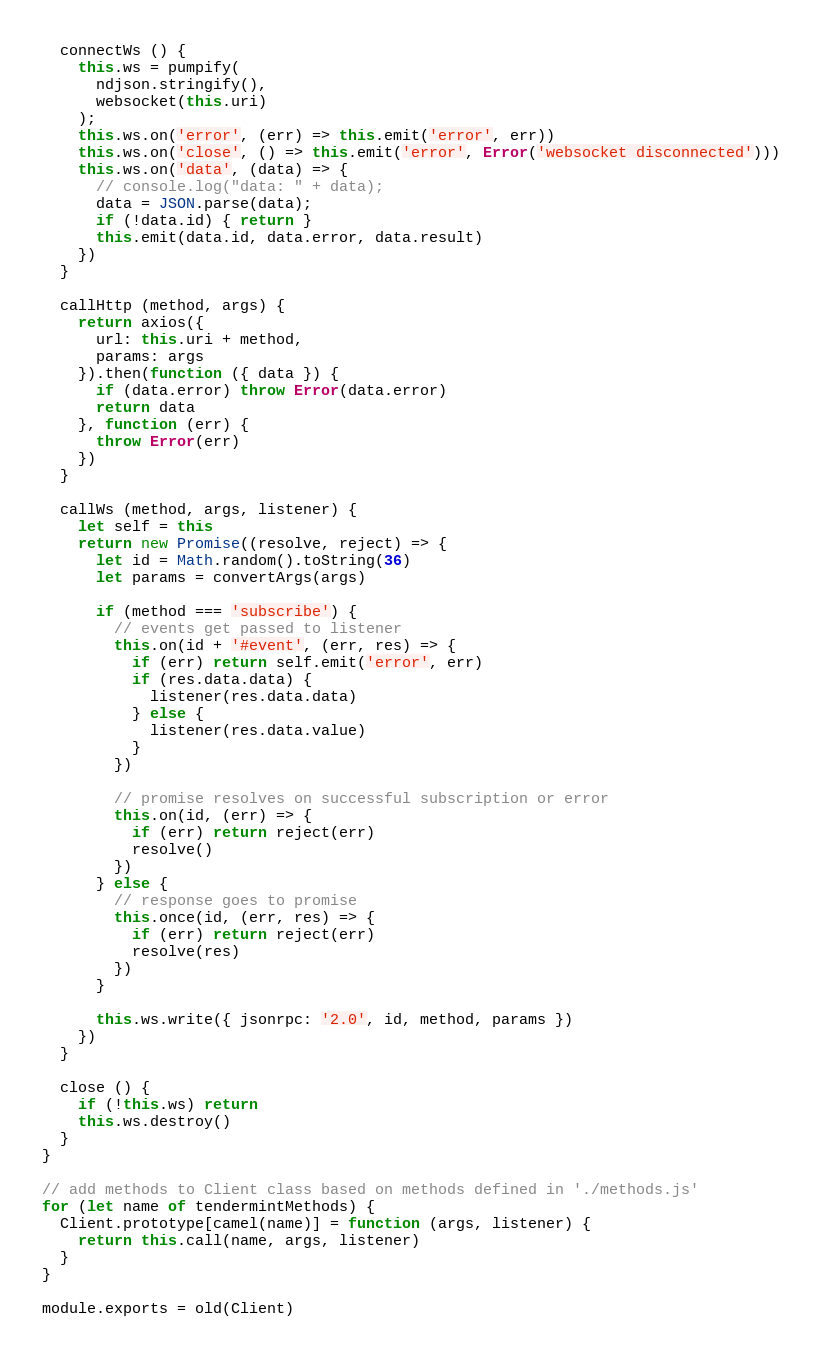<code> <loc_0><loc_0><loc_500><loc_500><_JavaScript_>
  connectWs () {
    this.ws = pumpify(
      ndjson.stringify(),
      websocket(this.uri)
    );
    this.ws.on('error', (err) => this.emit('error', err))
    this.ws.on('close', () => this.emit('error', Error('websocket disconnected')))
    this.ws.on('data', (data) => {
      // console.log("data: " + data);
      data = JSON.parse(data);
      if (!data.id) { return }
      this.emit(data.id, data.error, data.result)
    })
  }

  callHttp (method, args) {
    return axios({
      url: this.uri + method,
      params: args
    }).then(function ({ data }) {
      if (data.error) throw Error(data.error)
      return data
    }, function (err) {
      throw Error(err)
    })
  }

  callWs (method, args, listener) {
    let self = this
    return new Promise((resolve, reject) => {
      let id = Math.random().toString(36)
      let params = convertArgs(args)

      if (method === 'subscribe') {
        // events get passed to listener
        this.on(id + '#event', (err, res) => {
          if (err) return self.emit('error', err)
          if (res.data.data) {
            listener(res.data.data)
          } else {
            listener(res.data.value)
          }
        })

        // promise resolves on successful subscription or error
        this.on(id, (err) => {
          if (err) return reject(err)
          resolve()
        })
      } else {
        // response goes to promise
        this.once(id, (err, res) => {
          if (err) return reject(err)
          resolve(res)
        })
      }

      this.ws.write({ jsonrpc: '2.0', id, method, params })
    })
  }

  close () {
    if (!this.ws) return
    this.ws.destroy()
  }
}

// add methods to Client class based on methods defined in './methods.js'
for (let name of tendermintMethods) {
  Client.prototype[camel(name)] = function (args, listener) {
    return this.call(name, args, listener)
  }
}

module.exports = old(Client)
</code> 